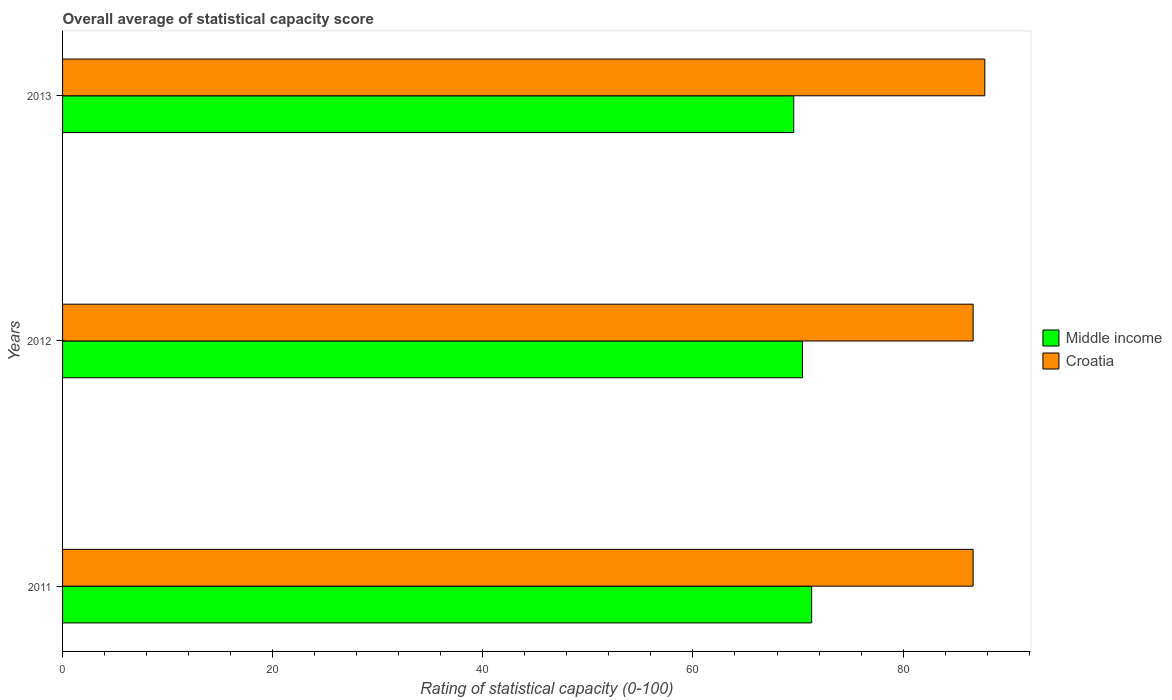How many bars are there on the 3rd tick from the top?
Your answer should be compact. 2. How many bars are there on the 2nd tick from the bottom?
Keep it short and to the point. 2. What is the label of the 2nd group of bars from the top?
Make the answer very short. 2012. What is the rating of statistical capacity in Croatia in 2012?
Your answer should be compact. 86.67. Across all years, what is the maximum rating of statistical capacity in Middle income?
Your answer should be compact. 71.3. Across all years, what is the minimum rating of statistical capacity in Middle income?
Offer a terse response. 69.59. In which year was the rating of statistical capacity in Middle income maximum?
Keep it short and to the point. 2011. In which year was the rating of statistical capacity in Middle income minimum?
Ensure brevity in your answer.  2013. What is the total rating of statistical capacity in Middle income in the graph?
Ensure brevity in your answer.  211.32. What is the difference between the rating of statistical capacity in Middle income in 2011 and that in 2013?
Keep it short and to the point. 1.7. What is the difference between the rating of statistical capacity in Croatia in 2011 and the rating of statistical capacity in Middle income in 2012?
Your response must be concise. 16.24. What is the average rating of statistical capacity in Croatia per year?
Your answer should be very brief. 87.04. In the year 2013, what is the difference between the rating of statistical capacity in Middle income and rating of statistical capacity in Croatia?
Offer a terse response. -18.19. What is the ratio of the rating of statistical capacity in Middle income in 2012 to that in 2013?
Offer a very short reply. 1.01. Is the rating of statistical capacity in Croatia in 2012 less than that in 2013?
Provide a short and direct response. Yes. What is the difference between the highest and the second highest rating of statistical capacity in Croatia?
Your response must be concise. 1.11. What is the difference between the highest and the lowest rating of statistical capacity in Croatia?
Your response must be concise. 1.11. What does the 2nd bar from the bottom in 2012 represents?
Offer a terse response. Croatia. How many bars are there?
Give a very brief answer. 6. What is the difference between two consecutive major ticks on the X-axis?
Offer a terse response. 20. Are the values on the major ticks of X-axis written in scientific E-notation?
Ensure brevity in your answer.  No. Where does the legend appear in the graph?
Provide a short and direct response. Center right. How many legend labels are there?
Your response must be concise. 2. What is the title of the graph?
Your answer should be very brief. Overall average of statistical capacity score. Does "Iran" appear as one of the legend labels in the graph?
Provide a short and direct response. No. What is the label or title of the X-axis?
Your response must be concise. Rating of statistical capacity (0-100). What is the Rating of statistical capacity (0-100) in Middle income in 2011?
Offer a very short reply. 71.3. What is the Rating of statistical capacity (0-100) in Croatia in 2011?
Provide a short and direct response. 86.67. What is the Rating of statistical capacity (0-100) in Middle income in 2012?
Provide a succinct answer. 70.43. What is the Rating of statistical capacity (0-100) of Croatia in 2012?
Provide a succinct answer. 86.67. What is the Rating of statistical capacity (0-100) in Middle income in 2013?
Give a very brief answer. 69.59. What is the Rating of statistical capacity (0-100) in Croatia in 2013?
Keep it short and to the point. 87.78. Across all years, what is the maximum Rating of statistical capacity (0-100) in Middle income?
Provide a short and direct response. 71.3. Across all years, what is the maximum Rating of statistical capacity (0-100) in Croatia?
Provide a short and direct response. 87.78. Across all years, what is the minimum Rating of statistical capacity (0-100) in Middle income?
Your answer should be very brief. 69.59. Across all years, what is the minimum Rating of statistical capacity (0-100) of Croatia?
Keep it short and to the point. 86.67. What is the total Rating of statistical capacity (0-100) in Middle income in the graph?
Provide a short and direct response. 211.32. What is the total Rating of statistical capacity (0-100) of Croatia in the graph?
Give a very brief answer. 261.11. What is the difference between the Rating of statistical capacity (0-100) of Middle income in 2011 and that in 2012?
Your response must be concise. 0.87. What is the difference between the Rating of statistical capacity (0-100) in Middle income in 2011 and that in 2013?
Offer a terse response. 1.7. What is the difference between the Rating of statistical capacity (0-100) in Croatia in 2011 and that in 2013?
Keep it short and to the point. -1.11. What is the difference between the Rating of statistical capacity (0-100) of Middle income in 2012 and that in 2013?
Offer a very short reply. 0.84. What is the difference between the Rating of statistical capacity (0-100) of Croatia in 2012 and that in 2013?
Your response must be concise. -1.11. What is the difference between the Rating of statistical capacity (0-100) in Middle income in 2011 and the Rating of statistical capacity (0-100) in Croatia in 2012?
Offer a very short reply. -15.37. What is the difference between the Rating of statistical capacity (0-100) in Middle income in 2011 and the Rating of statistical capacity (0-100) in Croatia in 2013?
Your response must be concise. -16.48. What is the difference between the Rating of statistical capacity (0-100) in Middle income in 2012 and the Rating of statistical capacity (0-100) in Croatia in 2013?
Keep it short and to the point. -17.35. What is the average Rating of statistical capacity (0-100) of Middle income per year?
Make the answer very short. 70.44. What is the average Rating of statistical capacity (0-100) in Croatia per year?
Give a very brief answer. 87.04. In the year 2011, what is the difference between the Rating of statistical capacity (0-100) of Middle income and Rating of statistical capacity (0-100) of Croatia?
Your response must be concise. -15.37. In the year 2012, what is the difference between the Rating of statistical capacity (0-100) of Middle income and Rating of statistical capacity (0-100) of Croatia?
Provide a succinct answer. -16.24. In the year 2013, what is the difference between the Rating of statistical capacity (0-100) of Middle income and Rating of statistical capacity (0-100) of Croatia?
Make the answer very short. -18.19. What is the ratio of the Rating of statistical capacity (0-100) of Middle income in 2011 to that in 2012?
Your response must be concise. 1.01. What is the ratio of the Rating of statistical capacity (0-100) of Middle income in 2011 to that in 2013?
Your response must be concise. 1.02. What is the ratio of the Rating of statistical capacity (0-100) of Croatia in 2011 to that in 2013?
Your response must be concise. 0.99. What is the ratio of the Rating of statistical capacity (0-100) of Croatia in 2012 to that in 2013?
Provide a succinct answer. 0.99. What is the difference between the highest and the second highest Rating of statistical capacity (0-100) of Middle income?
Provide a short and direct response. 0.87. What is the difference between the highest and the second highest Rating of statistical capacity (0-100) of Croatia?
Ensure brevity in your answer.  1.11. What is the difference between the highest and the lowest Rating of statistical capacity (0-100) in Middle income?
Your response must be concise. 1.7. What is the difference between the highest and the lowest Rating of statistical capacity (0-100) of Croatia?
Your answer should be very brief. 1.11. 